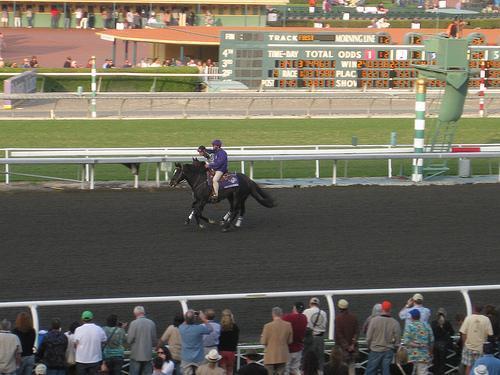How many jockeys are pictured?
Give a very brief answer. 2. 